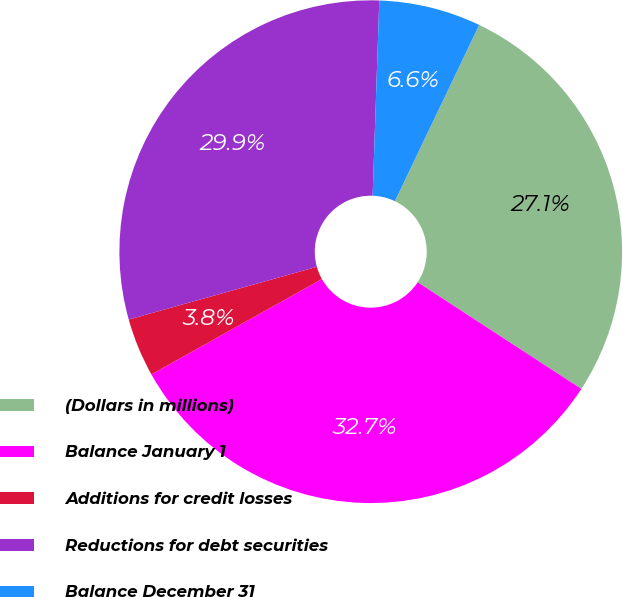<chart> <loc_0><loc_0><loc_500><loc_500><pie_chart><fcel>(Dollars in millions)<fcel>Balance January 1<fcel>Additions for credit losses<fcel>Reductions for debt securities<fcel>Balance December 31<nl><fcel>27.09%<fcel>32.69%<fcel>3.77%<fcel>29.89%<fcel>6.56%<nl></chart> 